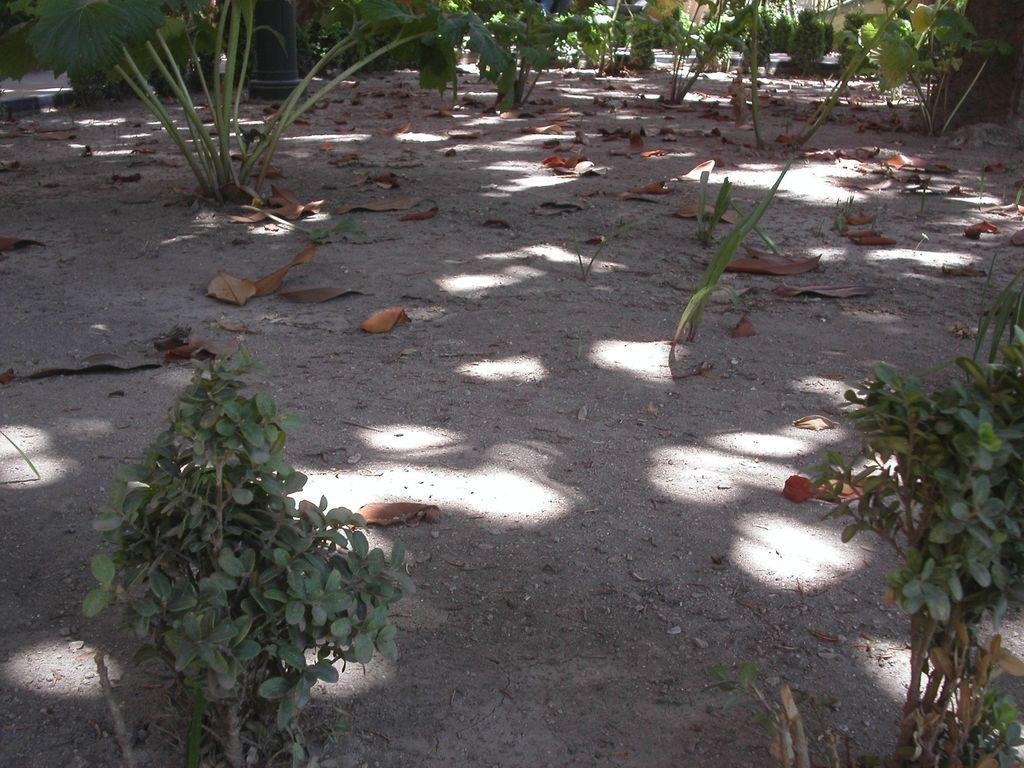What type of living organisms can be seen in the image? Plants can be seen in the image. What part of the plants is visible in the image? Leaves are visible in the image. What structure is present on the ground in the image? There is a pole on the ground in the image. What type of drink is being served in the alley in the image? There is no alley or drink present in the image; it features plants and a pole on the ground. 